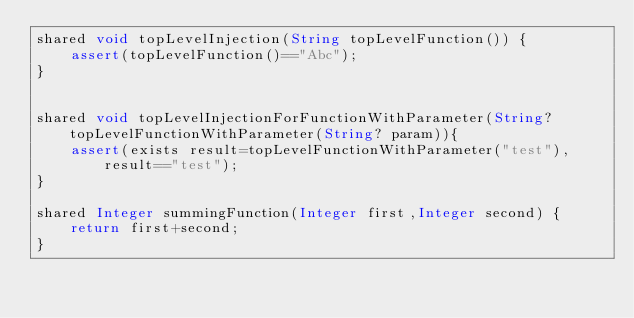<code> <loc_0><loc_0><loc_500><loc_500><_Ceylon_>shared void topLevelInjection(String topLevelFunction()) {
	assert(topLevelFunction()=="Abc");
}


shared void topLevelInjectionForFunctionWithParameter(String? topLevelFunctionWithParameter(String? param)){
	assert(exists result=topLevelFunctionWithParameter("test"),result=="test");
}

shared Integer summingFunction(Integer first,Integer second) {
	return first+second;
}</code> 